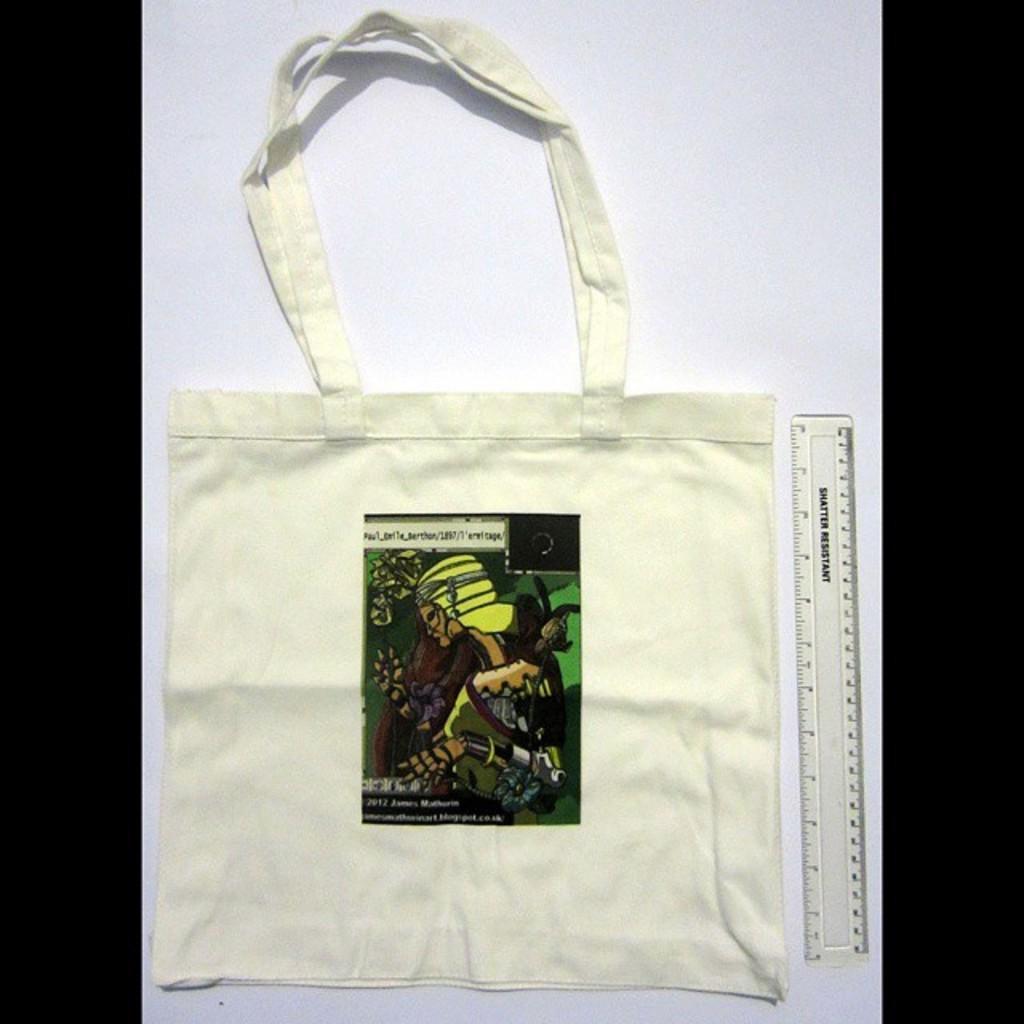Please provide a concise description of this image. Here we can see a bag and label on it, and at side here is the scale. 